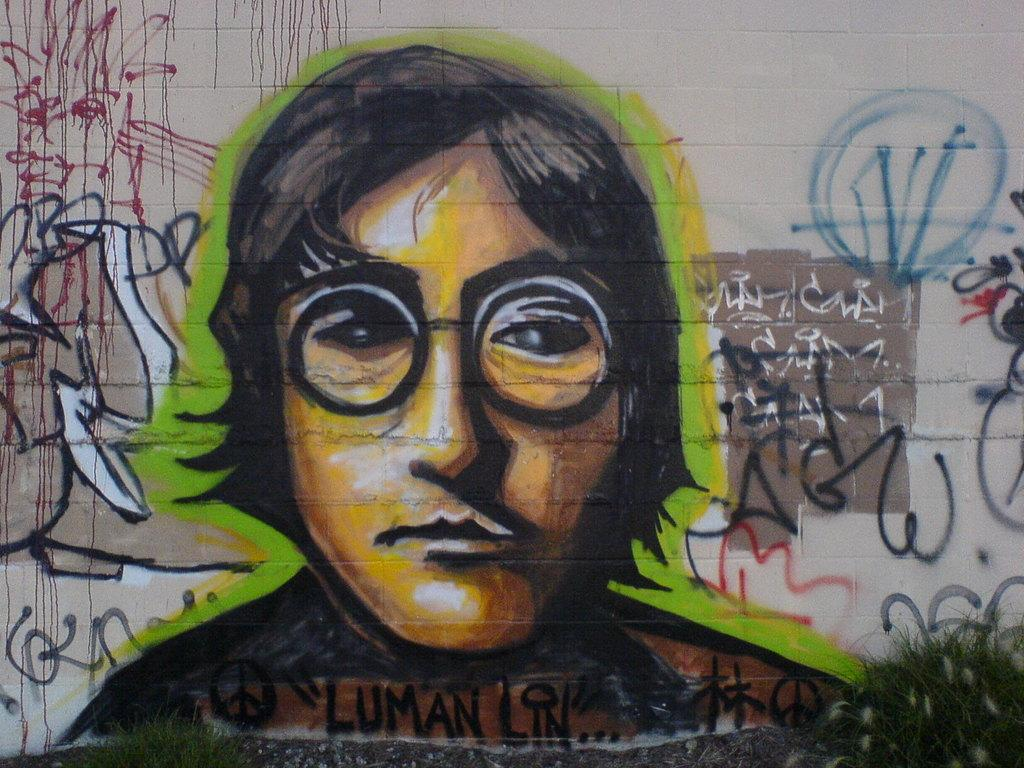What is the main subject of the wall painting in the image? The wall painting depicts a person with glasses. How would you describe the appearance of the wall painting? The wall painting is colorful. Are there any words or letters visible on the wall in the image? Yes, there is text written on the wall in the image. What type of bell can be heard ringing in the image? There is no bell present in the image, and therefore no sound can be heard. How many teeth does the person with glasses have in the image? The image only shows a wall painting of a person with glasses, and it does not depict the person's mouth or teeth. 